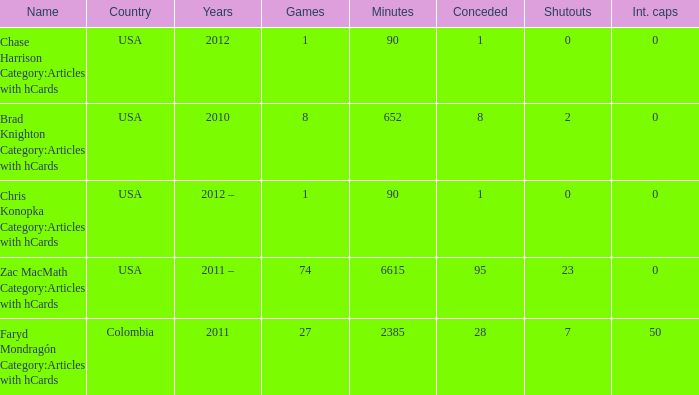When chase harrison category:articles with hcards is the name what is the year? 2012.0. 